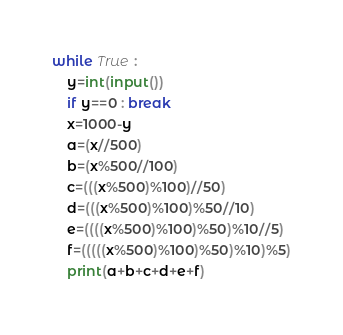<code> <loc_0><loc_0><loc_500><loc_500><_Python_>while True :
    y=int(input())
    if y==0 : break
    x=1000-y
    a=(x//500)
    b=(x%500//100)
    c=(((x%500)%100)//50)
    d=(((x%500)%100)%50//10)
    e=((((x%500)%100)%50)%10//5)
    f=(((((x%500)%100)%50)%10)%5)
    print(a+b+c+d+e+f)

</code> 